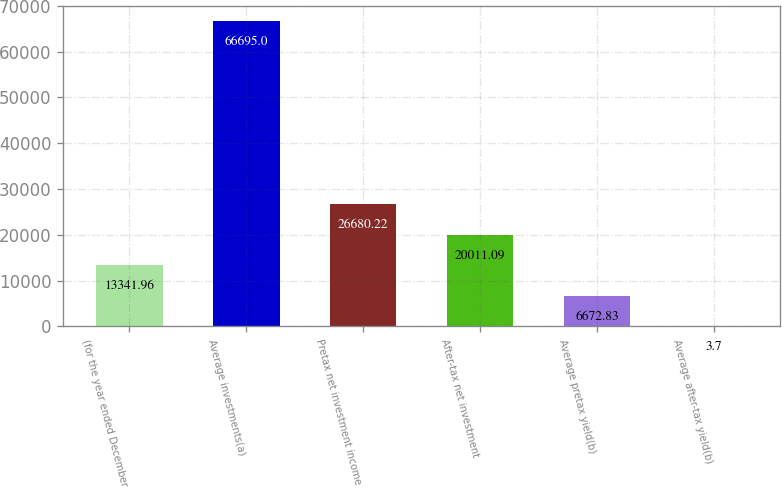Convert chart to OTSL. <chart><loc_0><loc_0><loc_500><loc_500><bar_chart><fcel>(for the year ended December<fcel>Average investments(a)<fcel>Pretax net investment income<fcel>After-tax net investment<fcel>Average pretax yield(b)<fcel>Average after-tax yield(b)<nl><fcel>13342<fcel>66695<fcel>26680.2<fcel>20011.1<fcel>6672.83<fcel>3.7<nl></chart> 